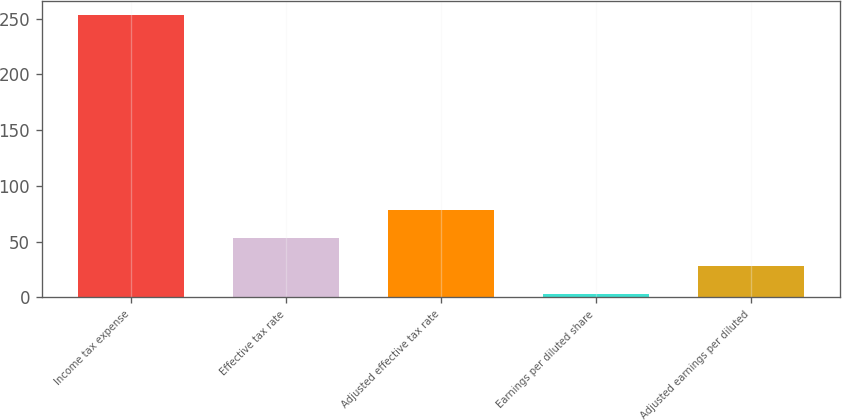Convert chart. <chart><loc_0><loc_0><loc_500><loc_500><bar_chart><fcel>Income tax expense<fcel>Effective tax rate<fcel>Adjusted effective tax rate<fcel>Earnings per diluted share<fcel>Adjusted earnings per diluted<nl><fcel>253<fcel>53.21<fcel>78.18<fcel>3.27<fcel>28.24<nl></chart> 